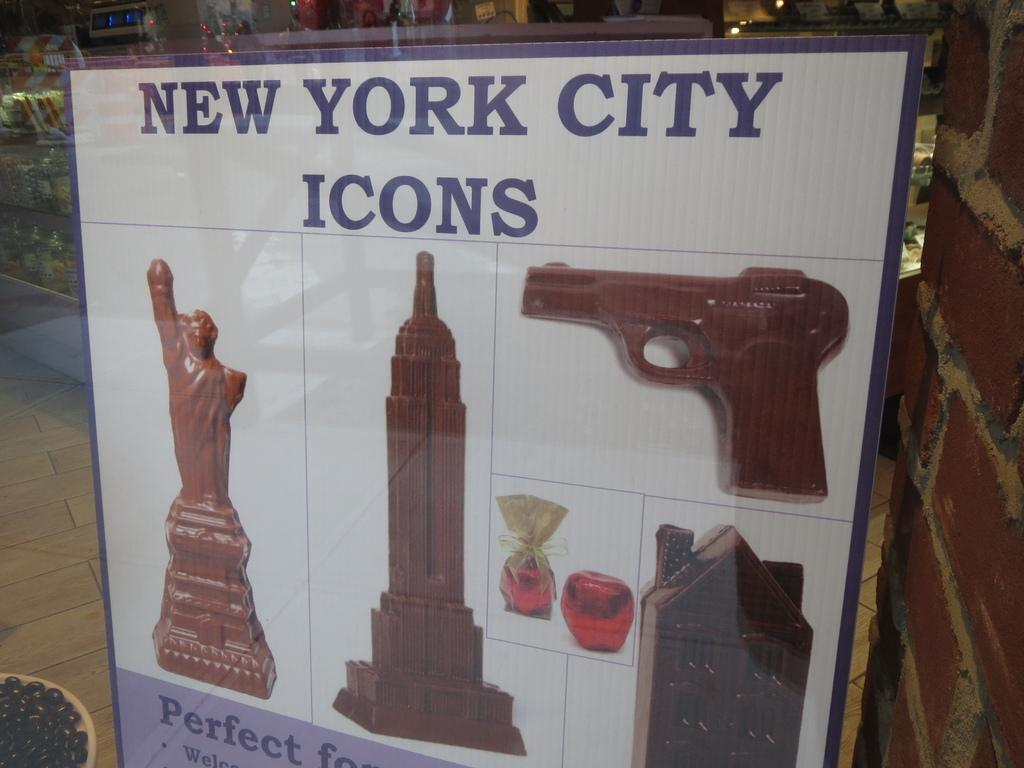<image>
Provide a brief description of the given image. A display of New York City icons seemingly made of chocolate. 